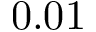Convert formula to latex. <formula><loc_0><loc_0><loc_500><loc_500>0 . 0 1</formula> 